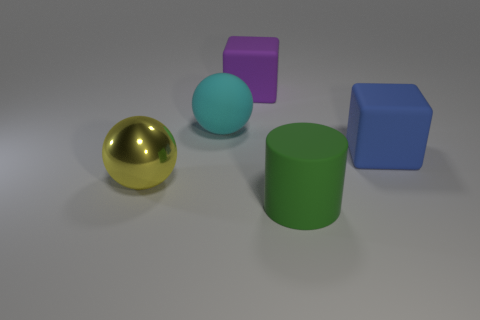Add 4 matte cylinders. How many objects exist? 9 Subtract all cylinders. How many objects are left? 4 Subtract all small green cylinders. Subtract all big cyan objects. How many objects are left? 4 Add 1 large things. How many large things are left? 6 Add 1 tiny blue balls. How many tiny blue balls exist? 1 Subtract 0 gray cubes. How many objects are left? 5 